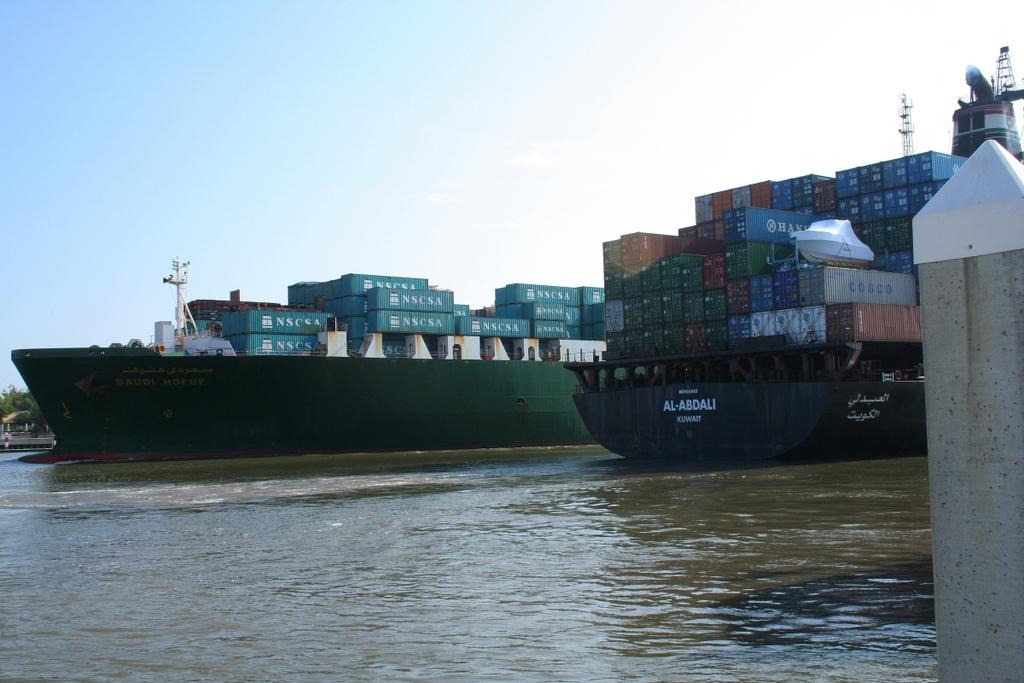<image>
Offer a succinct explanation of the picture presented. A ship called the Al-Abdali from Kuwait is at dock right now. 